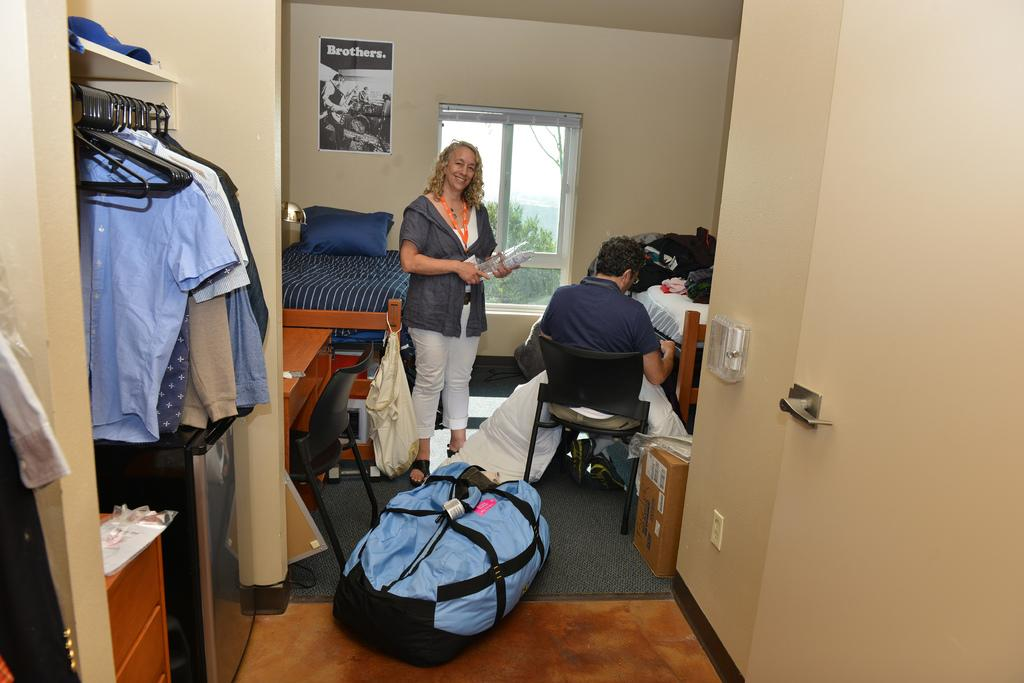What is the woman doing in the image? The woman is standing in the image. What is the man doing in the image? The man is sitting on a chair in the image. What can be seen on the floor in the image? There is a luggage bag on the floor in the image. What type of clothing is hanging in the image? There are shirts hanging on a hanger in the image. What type of bead is used to decorate the garden in the image? There is no garden or bead present in the image. 